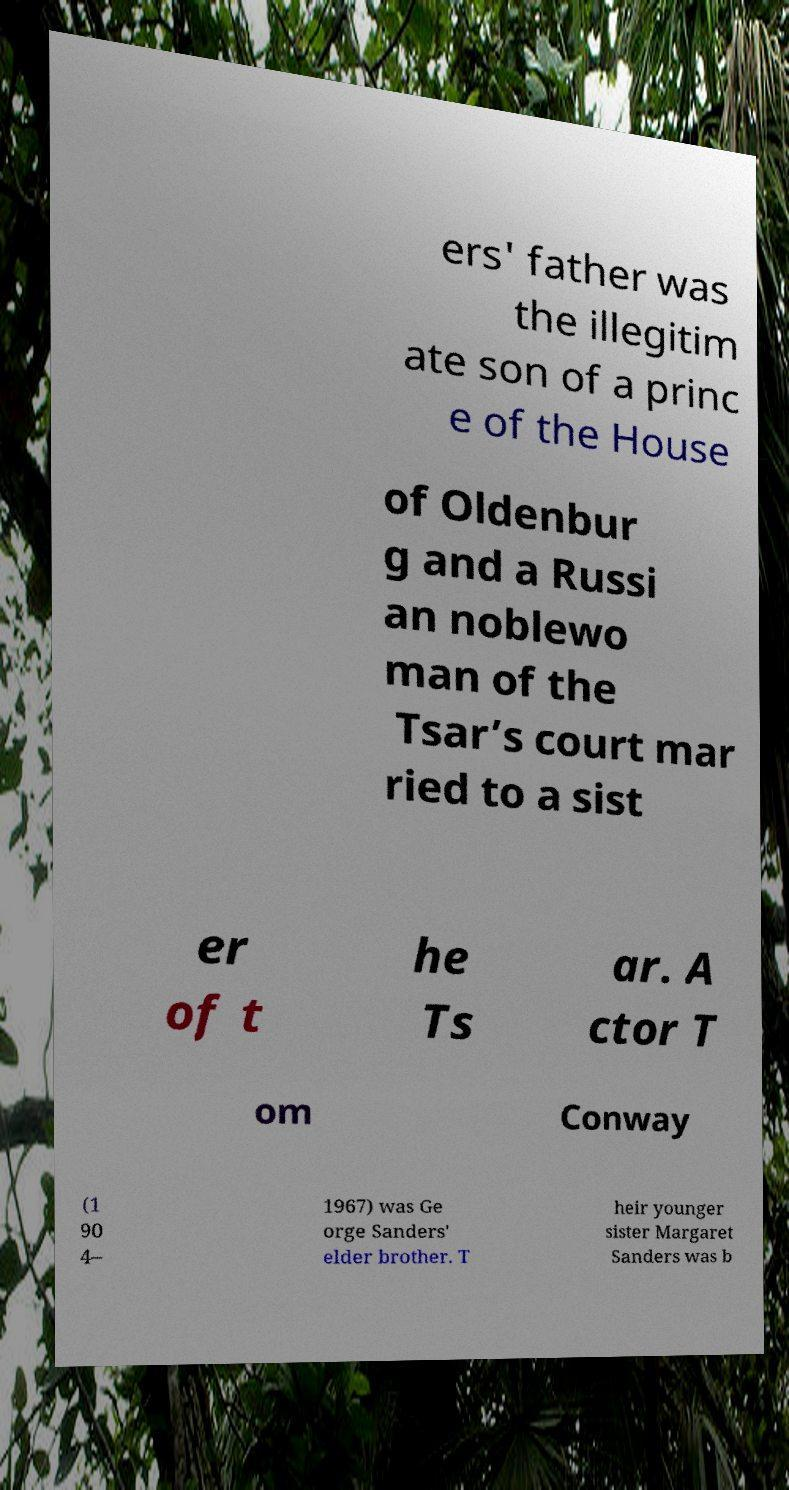I need the written content from this picture converted into text. Can you do that? ers' father was the illegitim ate son of a princ e of the House of Oldenbur g and a Russi an noblewo man of the Tsar’s court mar ried to a sist er of t he Ts ar. A ctor T om Conway (1 90 4– 1967) was Ge orge Sanders' elder brother. T heir younger sister Margaret Sanders was b 